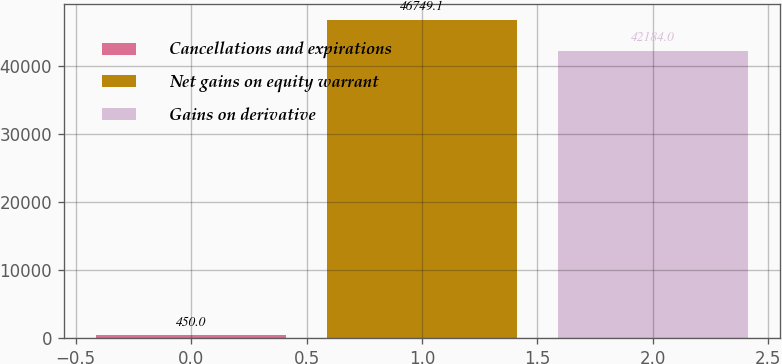Convert chart to OTSL. <chart><loc_0><loc_0><loc_500><loc_500><bar_chart><fcel>Cancellations and expirations<fcel>Net gains on equity warrant<fcel>Gains on derivative<nl><fcel>450<fcel>46749.1<fcel>42184<nl></chart> 